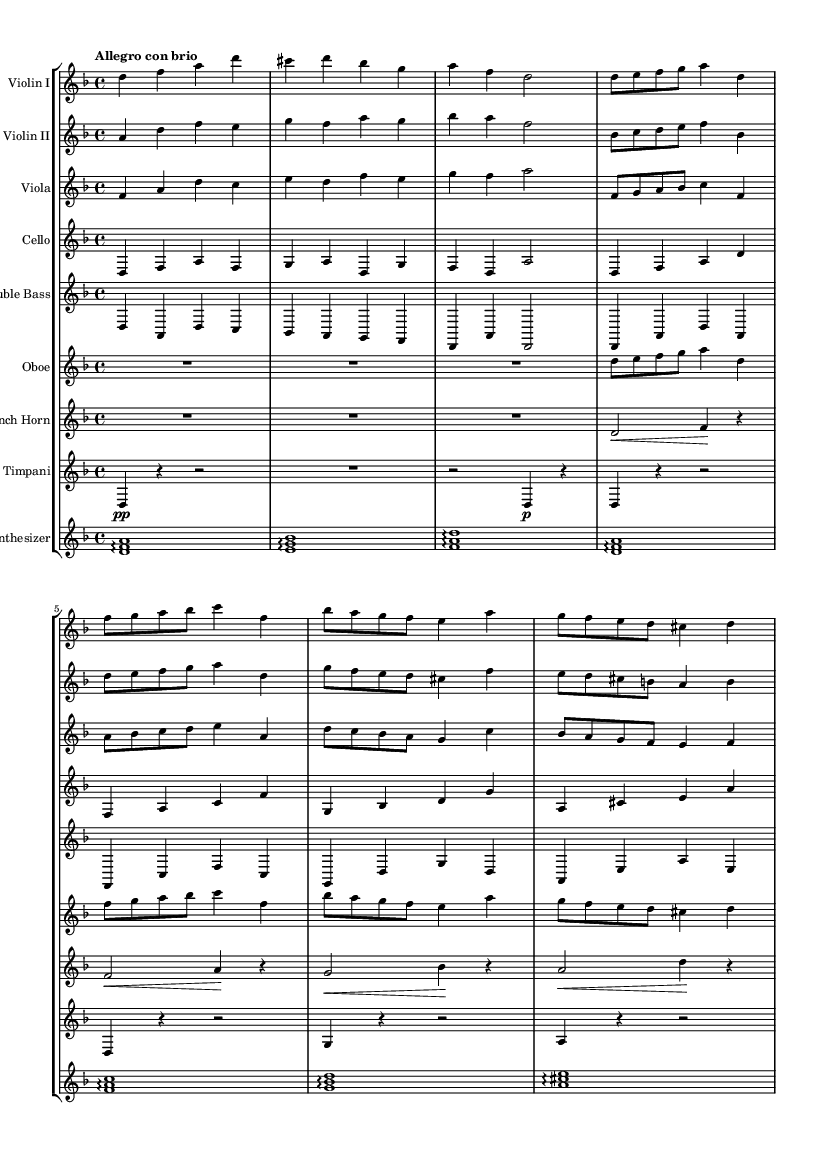What is the key signature of this music? The key signature is D minor, which has one flat (B♭). This can be determined by looking at the key signature section at the beginning of the score.
Answer: D minor What is the time signature of this music? The time signature is 4/4, indicating that there are four beats in each measure and the quarter note gets one beat. This is located at the start of the piece, following the key signature.
Answer: 4/4 What is the tempo marking for this piece? The tempo marking is "Allegro con brio," indicating a lively pace. This marking is placed at the beginning of the score and suggests the desired speed and character.
Answer: Allegro con brio How many measures are there in the provided music? There are 16 measures in total. This can be counted by examining the measures delineated by vertical lines throughout the score.
Answer: 16 What instruments are included in this arrangement? The instruments included are Violin I, Violin II, Viola, Cello, Double Bass, Oboe, French Horn, Timpani, and Synthesizer. This information can be found at the beginning of each staff to specify which instrument plays each part.
Answer: Violin I, Violin II, Viola, Cello, Double Bass, Oboe, French Horn, Timpani, Synthesizer Which themes are abbreviated in the music? The music contains Theme A and Theme B, both of which are abbreviated. This can be inferred from the labels within the score that refer to "Theme A" and "Theme B," indicating that only part of these themes is presented.
Answer: Theme A, Theme B What is the role of the synthesizer in this piece? The synthesizer serves to provide harmonic support and fills the textures created by the string and wind instruments. Its presence is noted in the score as a distinctive part that complements the orchestral arrangement.
Answer: Harmonic support 